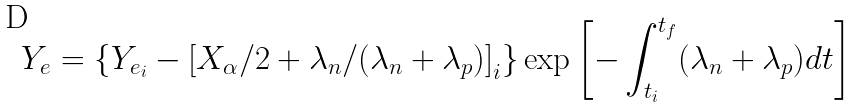Convert formula to latex. <formula><loc_0><loc_0><loc_500><loc_500>Y _ { e } = \{ { Y _ { e _ { i } } - { [ X _ { \alpha } / 2 + \lambda _ { n } / ( \lambda _ { n } + \lambda _ { p } ) ] } _ { i } } \} \exp { \left [ - \int _ { t _ { i } } ^ { t _ { f } } ( \lambda _ { n } + \lambda _ { p } ) d t \right ] }</formula> 